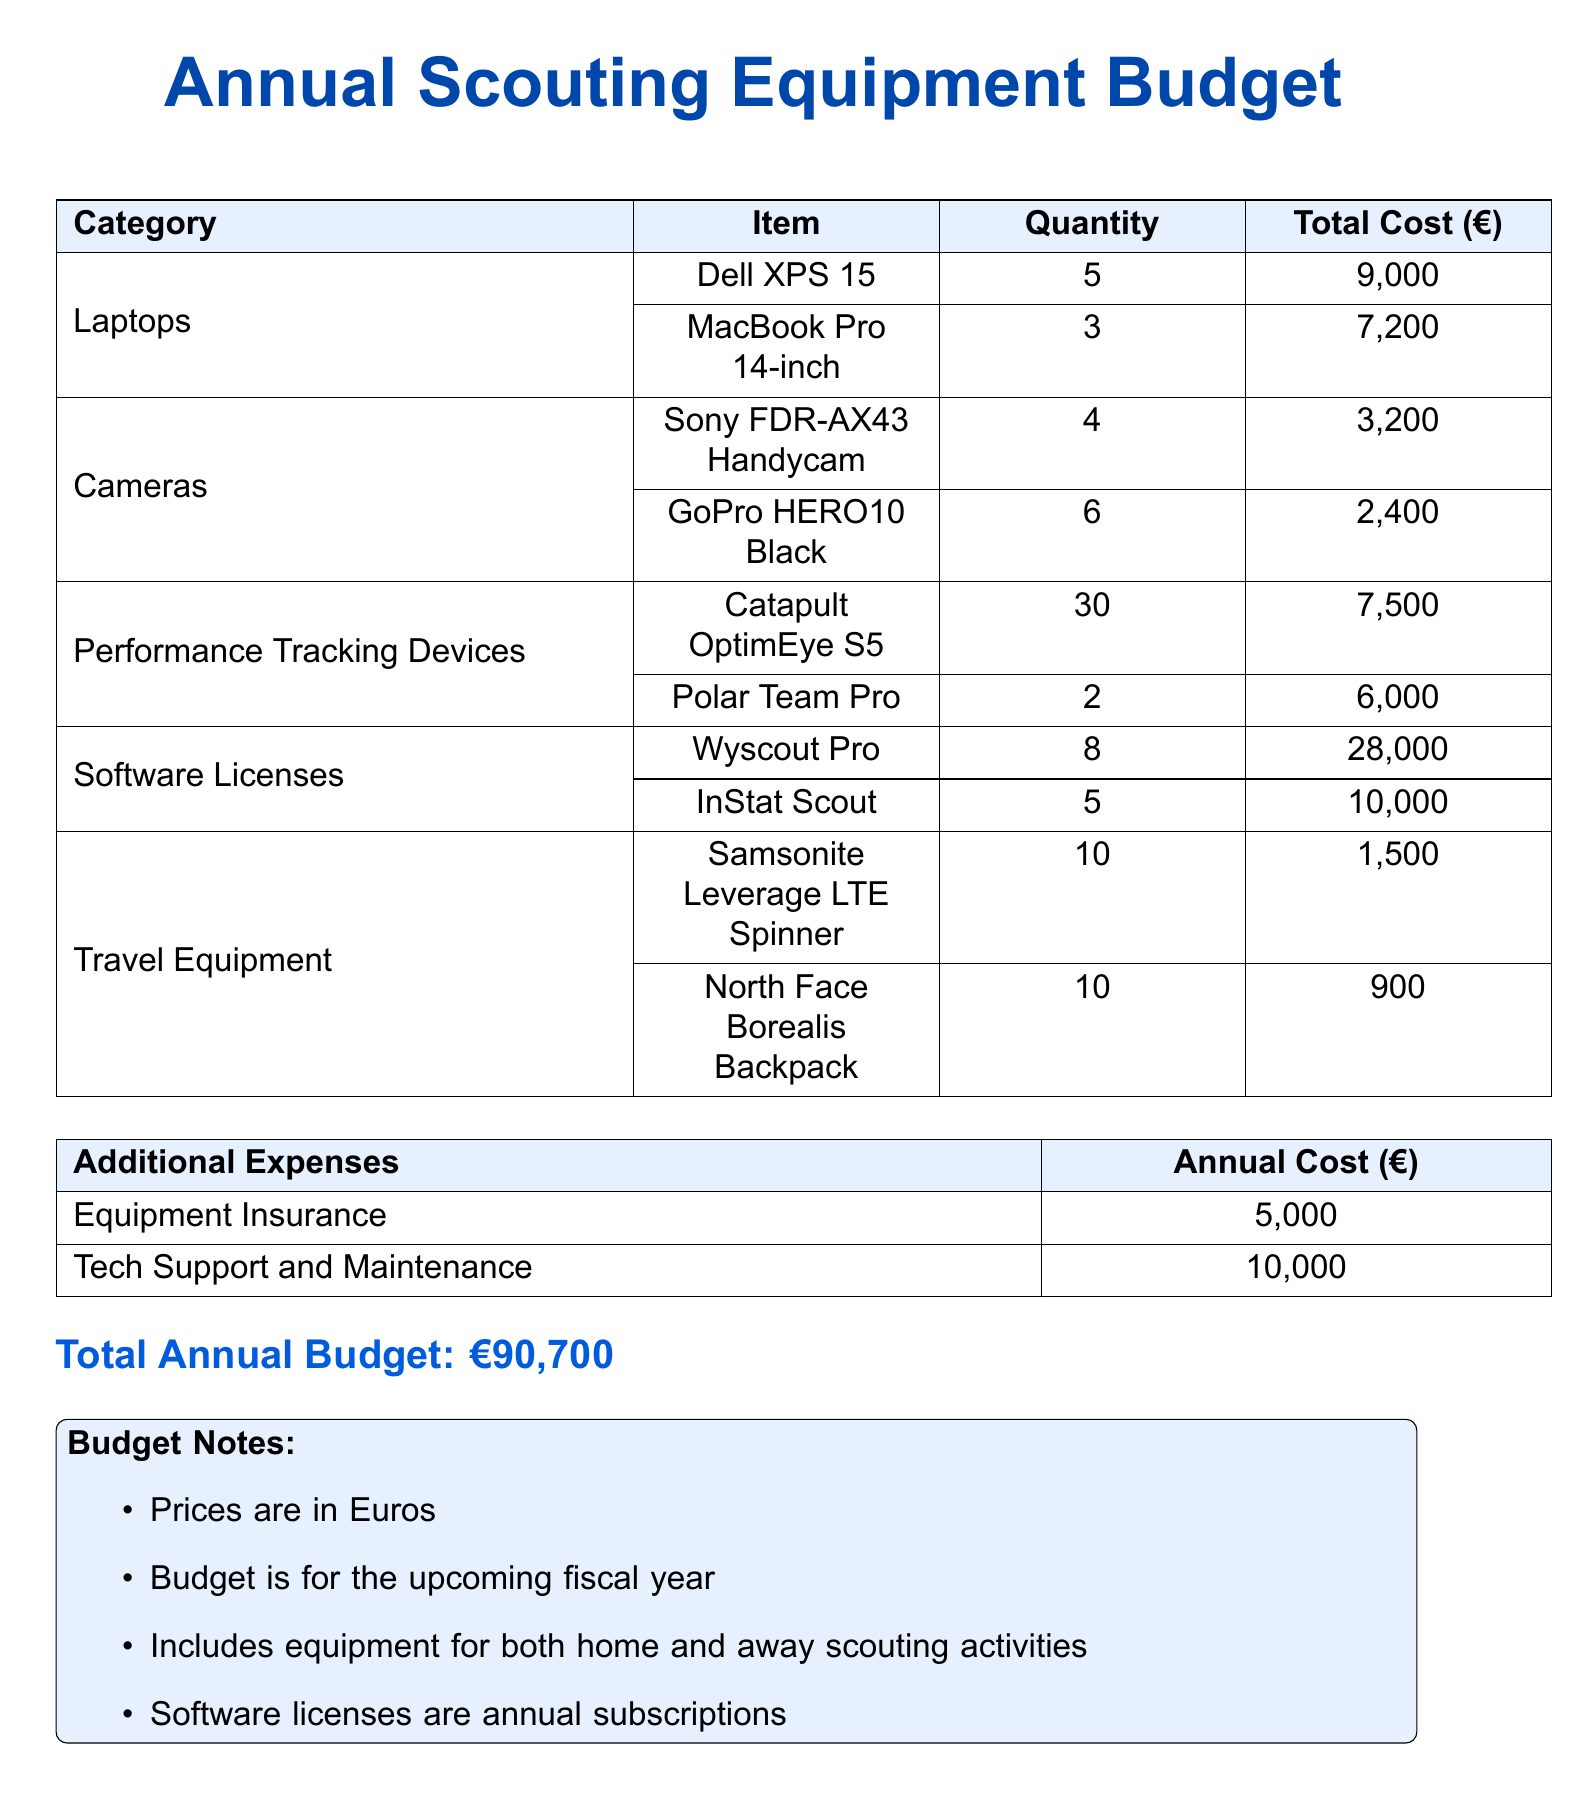What is the total cost for laptops? The total cost for laptops is the sum of the individual costs of each laptop. Therefore, it is €9,000 + €7,200 = €16,200.
Answer: €16,200 How many cameras are included in the budget? The total number of cameras is the sum of the individual cameras listed. Therefore, it is 4 + 6 = 10.
Answer: 10 What is the cost of the Catapult OptimEye S5 devices? The total cost is given directly in the budget table for the Catapult OptimEye S5, which is €7,500.
Answer: €7,500 What is the budget for travel equipment? The total cost for travel equipment is the sum of the individual items listed, which is €1,500 + €900 = €2,400.
Answer: €2,400 How many software licenses for Wyscout Pro are included? The document states that there are 8 Wyscout Pro software licenses included in the budget.
Answer: 8 What is the annual cost for equipment insurance? The document specifies that the annual cost for equipment insurance is €5,000.
Answer: €5,000 How many performance tracking devices are there in total? The total number of performance tracking devices is the sum of the devices listed, which is 30 + 2 = 32.
Answer: 32 What is the total annual budget? The total annual budget is listed explicitly in the document as €90,700.
Answer: €90,700 What item has the highest total cost? The item with the highest total cost is Wyscout Pro with a total cost of €28,000.
Answer: Wyscout Pro 